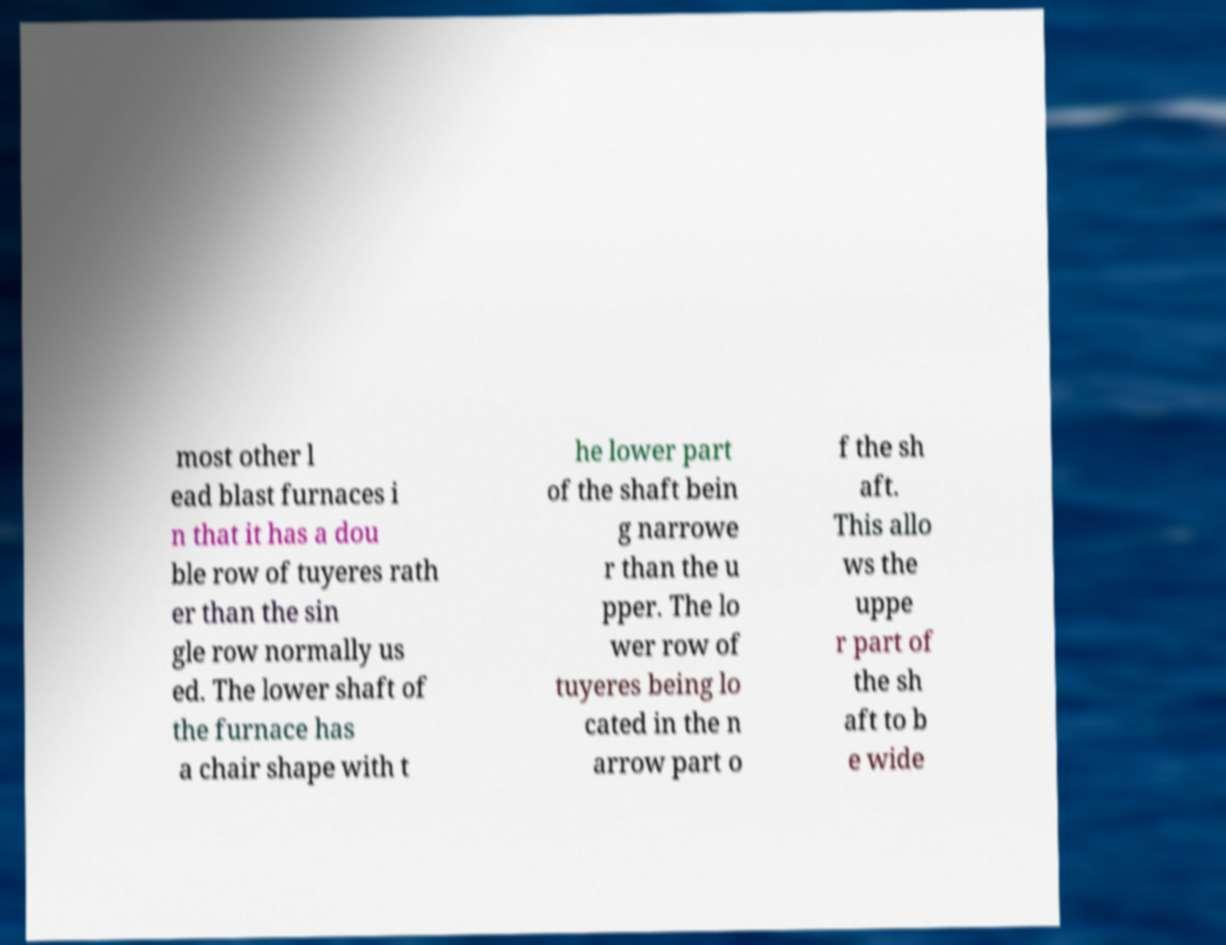Please read and relay the text visible in this image. What does it say? most other l ead blast furnaces i n that it has a dou ble row of tuyeres rath er than the sin gle row normally us ed. The lower shaft of the furnace has a chair shape with t he lower part of the shaft bein g narrowe r than the u pper. The lo wer row of tuyeres being lo cated in the n arrow part o f the sh aft. This allo ws the uppe r part of the sh aft to b e wide 